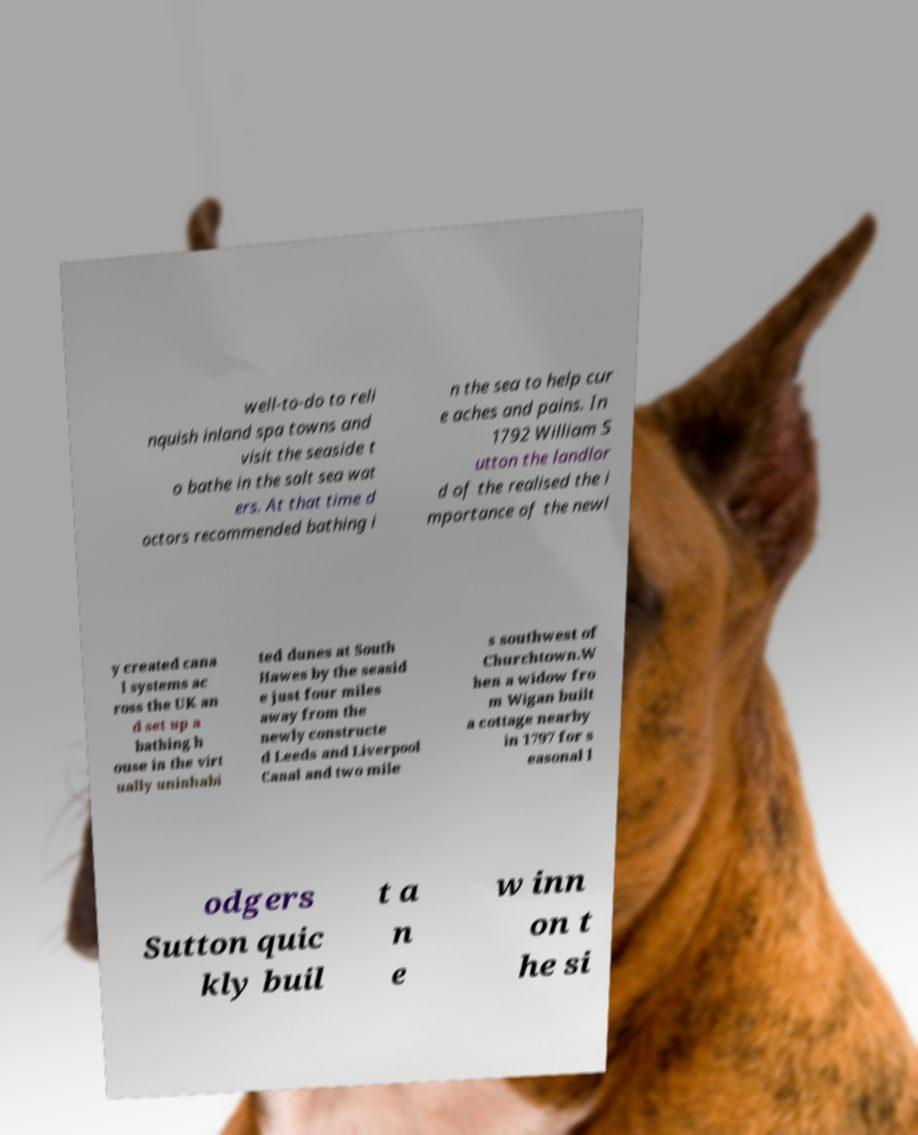Could you assist in decoding the text presented in this image and type it out clearly? well-to-do to reli nquish inland spa towns and visit the seaside t o bathe in the salt sea wat ers. At that time d octors recommended bathing i n the sea to help cur e aches and pains. In 1792 William S utton the landlor d of the realised the i mportance of the newl y created cana l systems ac ross the UK an d set up a bathing h ouse in the virt ually uninhabi ted dunes at South Hawes by the seasid e just four miles away from the newly constructe d Leeds and Liverpool Canal and two mile s southwest of Churchtown.W hen a widow fro m Wigan built a cottage nearby in 1797 for s easonal l odgers Sutton quic kly buil t a n e w inn on t he si 